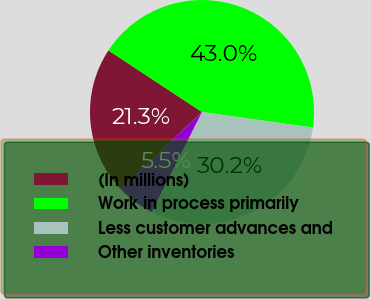<chart> <loc_0><loc_0><loc_500><loc_500><pie_chart><fcel>(In millions)<fcel>Work in process primarily<fcel>Less customer advances and<fcel>Other inventories<nl><fcel>21.34%<fcel>42.95%<fcel>30.19%<fcel>5.51%<nl></chart> 